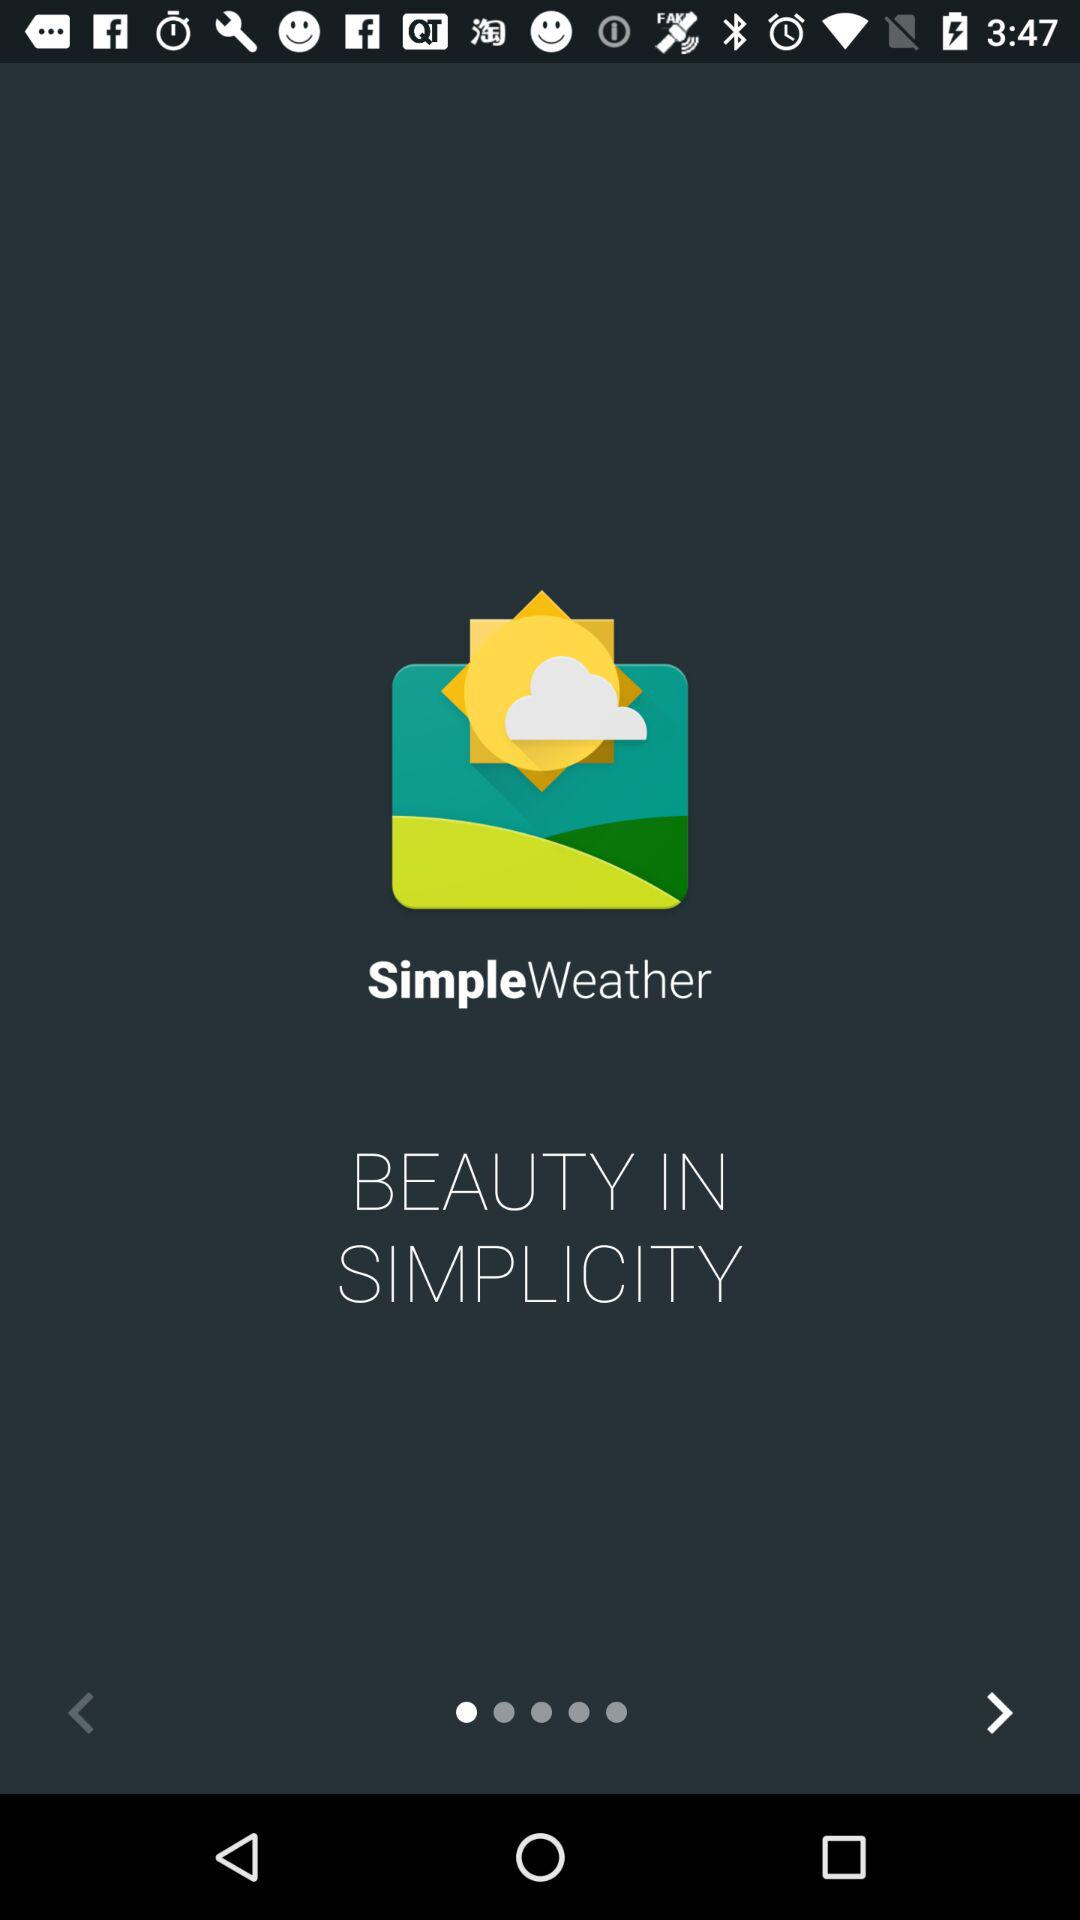What is the name of the application? The name of the application is "SimpleWeather". 